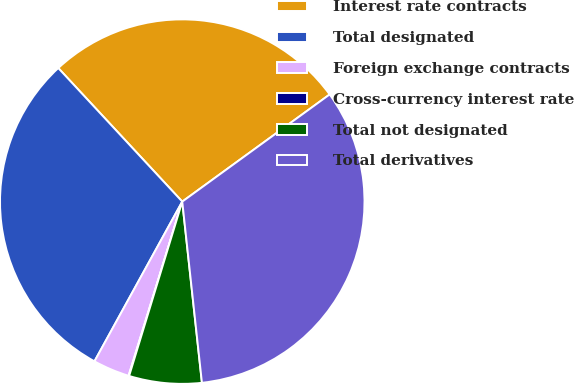Convert chart to OTSL. <chart><loc_0><loc_0><loc_500><loc_500><pie_chart><fcel>Interest rate contracts<fcel>Total designated<fcel>Foreign exchange contracts<fcel>Cross-currency interest rate<fcel>Total not designated<fcel>Total derivatives<nl><fcel>26.9%<fcel>30.09%<fcel>3.24%<fcel>0.05%<fcel>6.43%<fcel>33.28%<nl></chart> 